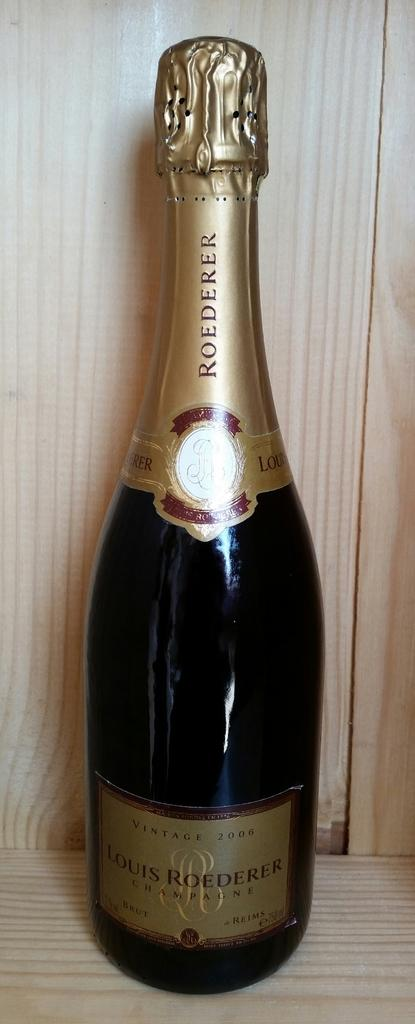<image>
Write a terse but informative summary of the picture. An unopened bottle of Louis Roederer Champagne is standing upright on a wooden shelf. 